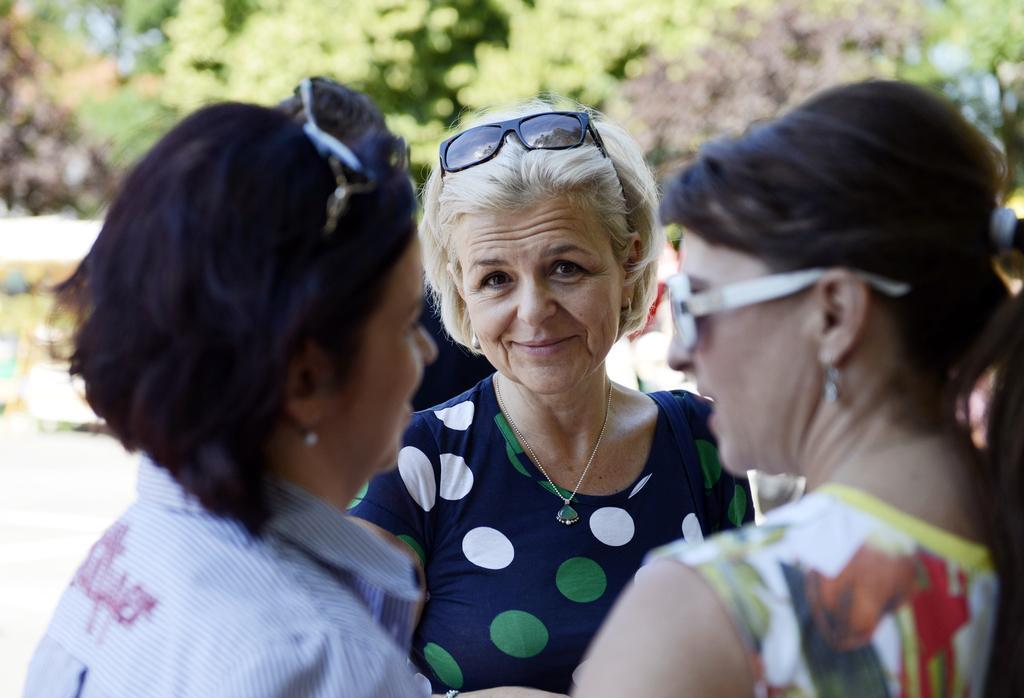Please provide a concise description of this image. In this image we can see three women. One is wearing shirt, the other one is wearing blue color t-shirt and the third one is wearing white and yellow color dress. Behind the woman trees are there. 